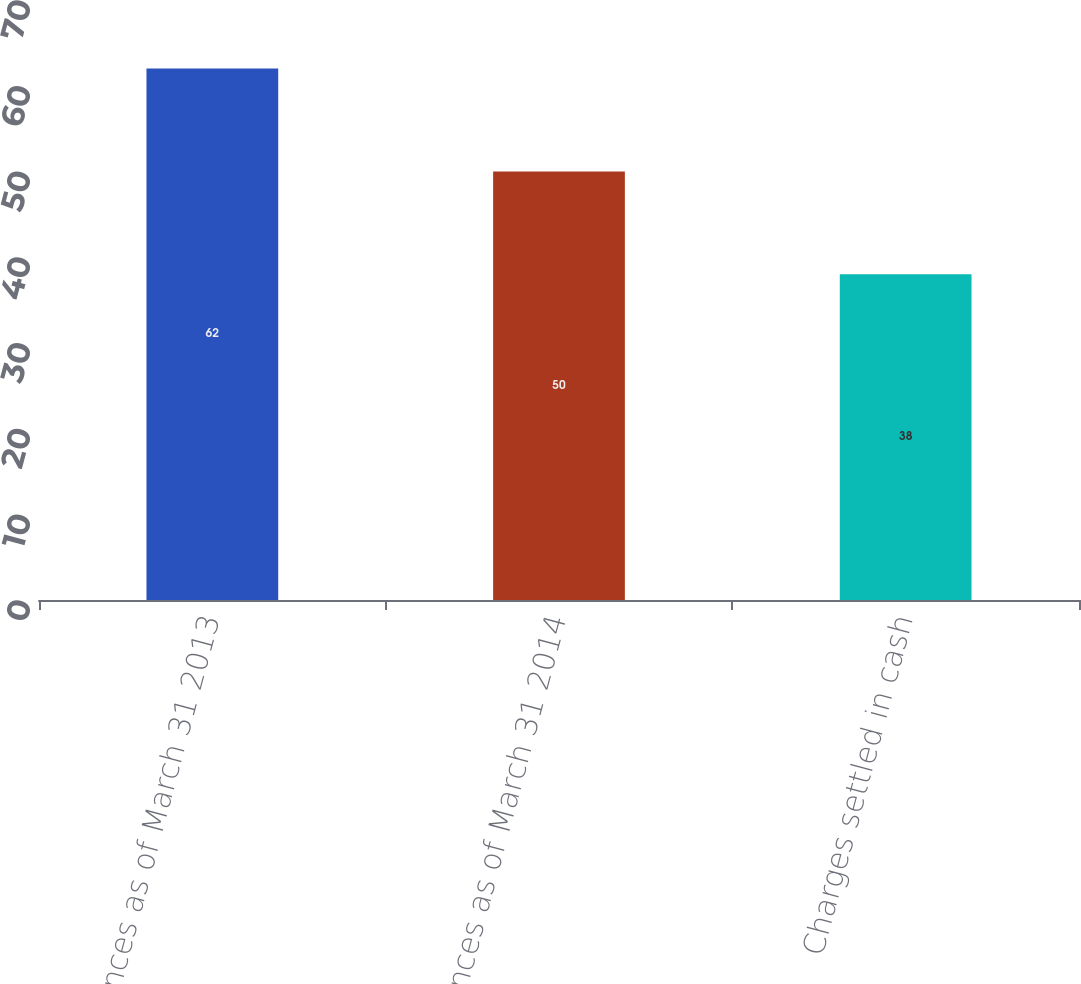<chart> <loc_0><loc_0><loc_500><loc_500><bar_chart><fcel>Balances as of March 31 2013<fcel>Balances as of March 31 2014<fcel>Charges settled in cash<nl><fcel>62<fcel>50<fcel>38<nl></chart> 